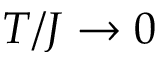Convert formula to latex. <formula><loc_0><loc_0><loc_500><loc_500>T / J \rightarrow 0</formula> 